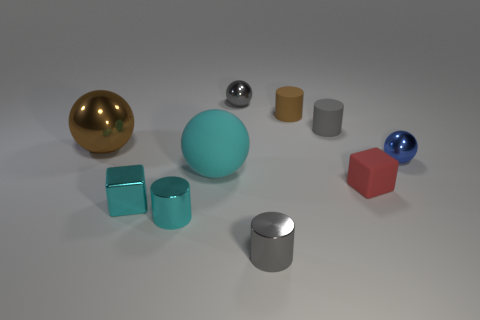Subtract all tiny gray spheres. How many spheres are left? 3 Subtract all brown cylinders. How many cylinders are left? 3 Subtract 4 spheres. How many spheres are left? 0 Add 5 purple metal balls. How many purple metal balls exist? 5 Subtract 0 green cylinders. How many objects are left? 10 Subtract all blocks. How many objects are left? 8 Subtract all blue cylinders. Subtract all red spheres. How many cylinders are left? 4 Subtract all green cylinders. How many brown balls are left? 1 Subtract all tiny yellow rubber cylinders. Subtract all rubber cubes. How many objects are left? 9 Add 2 tiny red rubber cubes. How many tiny red rubber cubes are left? 3 